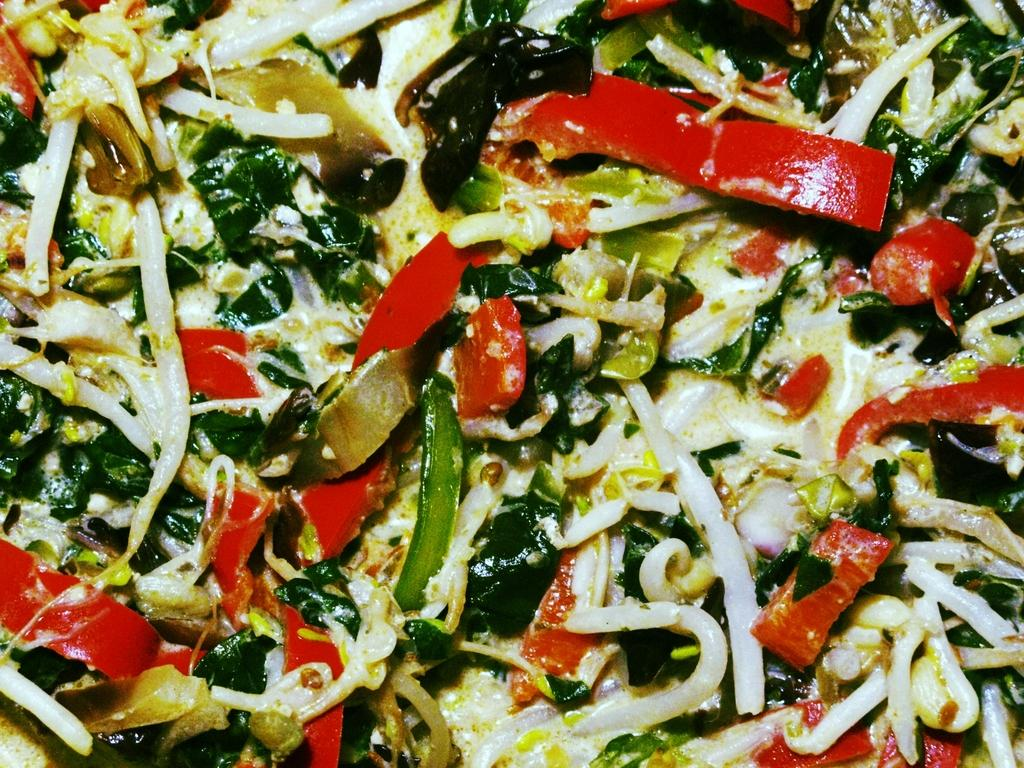What types of items can be seen in the image? There are food items in the image. Can you describe the food items in more detail? The food items include vegetable pieces. Where is the girl swimming in the ocean in the image? There is no girl swimming in the ocean in the image; it only contains food items and vegetable pieces. 